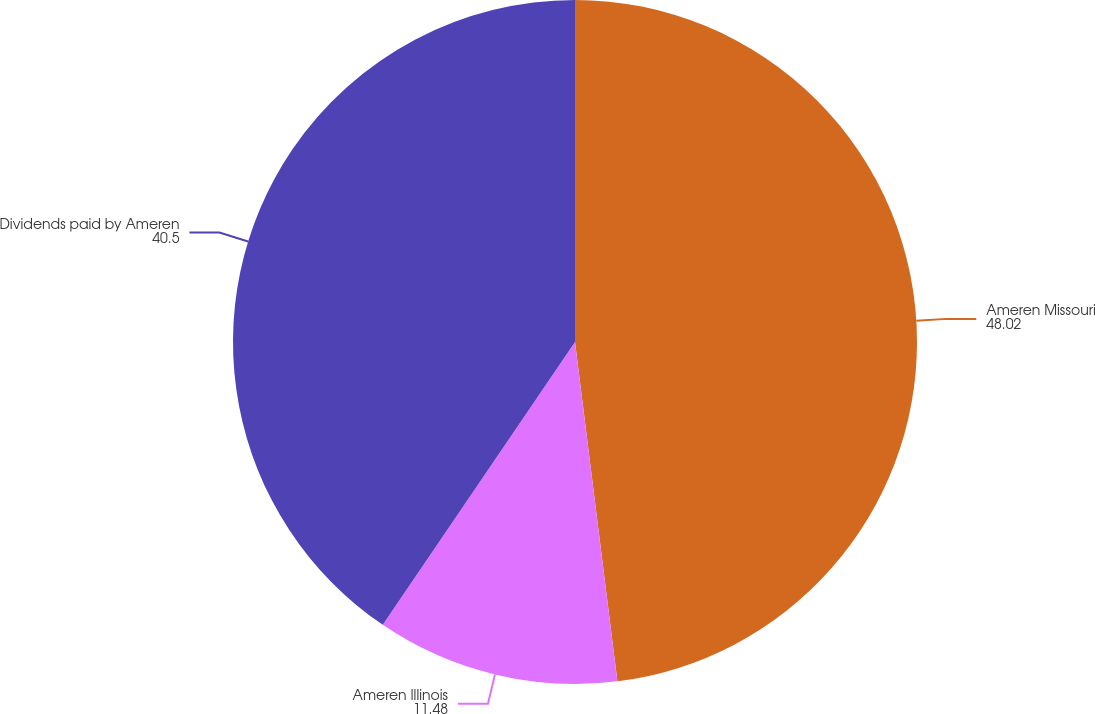Convert chart. <chart><loc_0><loc_0><loc_500><loc_500><pie_chart><fcel>Ameren Missouri<fcel>Ameren Illinois<fcel>Dividends paid by Ameren<nl><fcel>48.02%<fcel>11.48%<fcel>40.5%<nl></chart> 